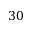Convert formula to latex. <formula><loc_0><loc_0><loc_500><loc_500>3 0</formula> 